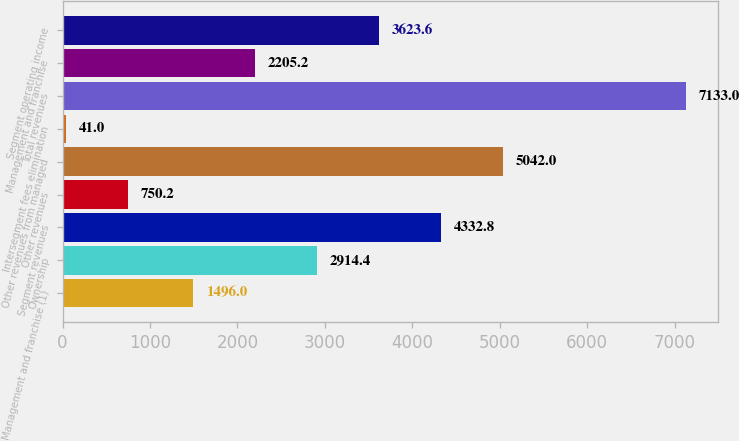Convert chart. <chart><loc_0><loc_0><loc_500><loc_500><bar_chart><fcel>Management and franchise (1)<fcel>Ownership<fcel>Segment revenues<fcel>Other revenues<fcel>Other revenues from managed<fcel>Intersegment fees elimination<fcel>Total revenues<fcel>Management and franchise<fcel>Segment operating income<nl><fcel>1496<fcel>2914.4<fcel>4332.8<fcel>750.2<fcel>5042<fcel>41<fcel>7133<fcel>2205.2<fcel>3623.6<nl></chart> 